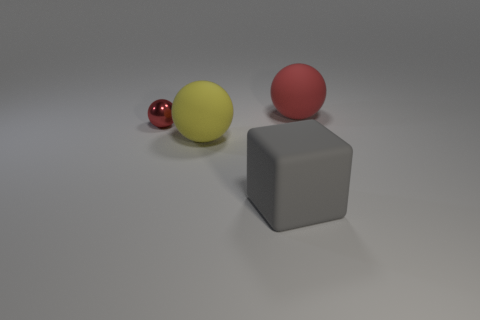Add 4 red matte things. How many objects exist? 8 Subtract all blue cubes. Subtract all gray cylinders. How many cubes are left? 1 Subtract all spheres. How many objects are left? 1 Subtract 0 green cylinders. How many objects are left? 4 Subtract all spheres. Subtract all large yellow spheres. How many objects are left? 0 Add 2 large gray cubes. How many large gray cubes are left? 3 Add 2 yellow cubes. How many yellow cubes exist? 2 